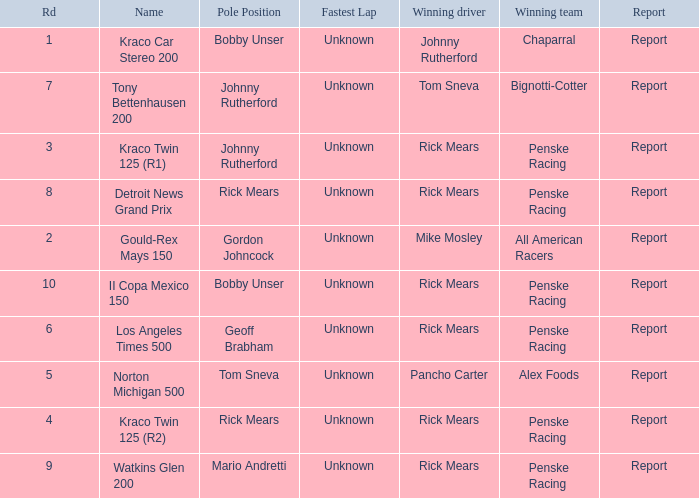What are the races that johnny rutherford has won? Kraco Car Stereo 200. 